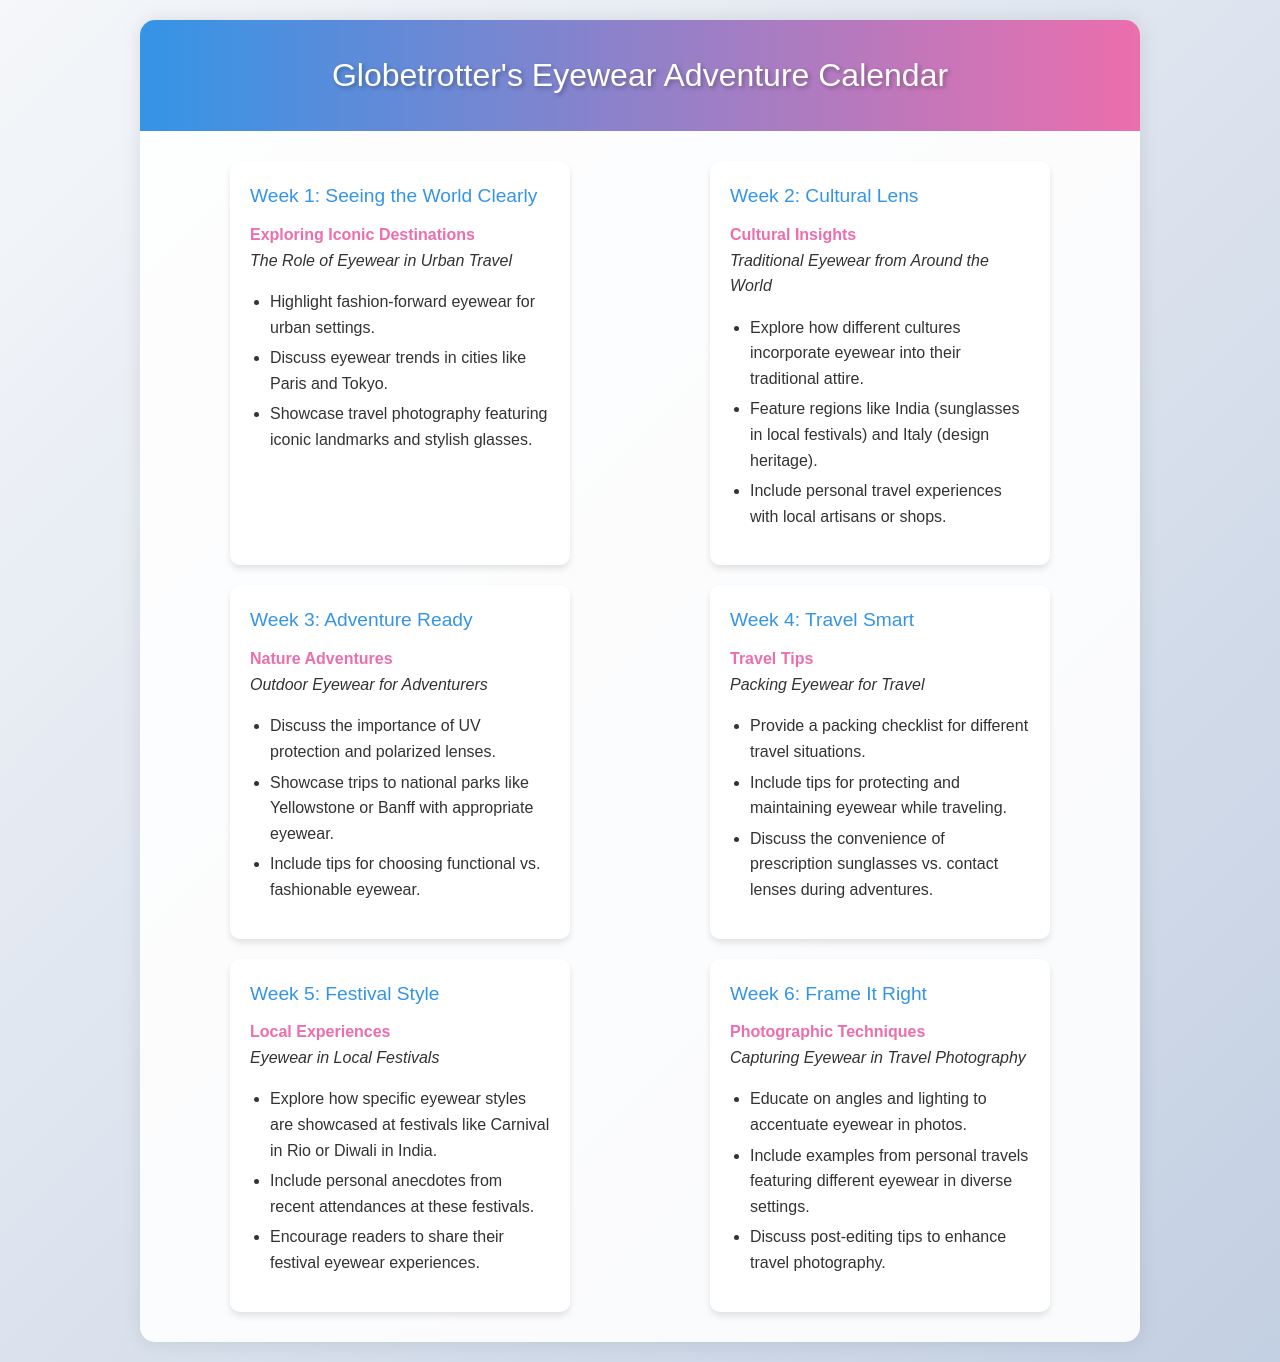What is the title of the document? The title appears in the header of the document, which states "Globetrotter's Eyewear Adventure Calendar."
Answer: Globetrotter's Eyewear Adventure Calendar How many weeks of content are outlined? Each week is represented by a week card, and there are six week cards displayed in the document.
Answer: 6 What theme is associated with Week 2? The theme for Week 2 is stated clearly within the week card dedicated to that week.
Answer: Cultural Insights What is the topic for Week 4? The topic can be found within the week card for Week 4, specifying the focus for that week.
Answer: Packing Eyewear for Travel Which location is mentioned in connection with outdoor eyewear? The text under Week 3 references specific national parks as examples for outdoor adventures.
Answer: Yellowstone Which festival is highlighted in Week 5? The document includes specific festivals within the content of Week 5’s topic, as an example to discuss.
Answer: Carnival in Rio What type of eyewear is mentioned for urban travel in Week 1? The week card for Week 1 specifies the focus on fashion-forward eyewear in urban settings.
Answer: Fashion-forward eyewear What advice is given regarding eyewear maintenance during travel? The packing tips provided in Week 4 include a focus on protecting and maintaining eyewear while traveling.
Answer: Protecting and maintaining eyewear How is photography of eyewear emphasized in Week 6? Week 6 discusses specific techniques related to capturing eyewear in travel photography with a focus on angles and lighting.
Answer: Angles and lighting 